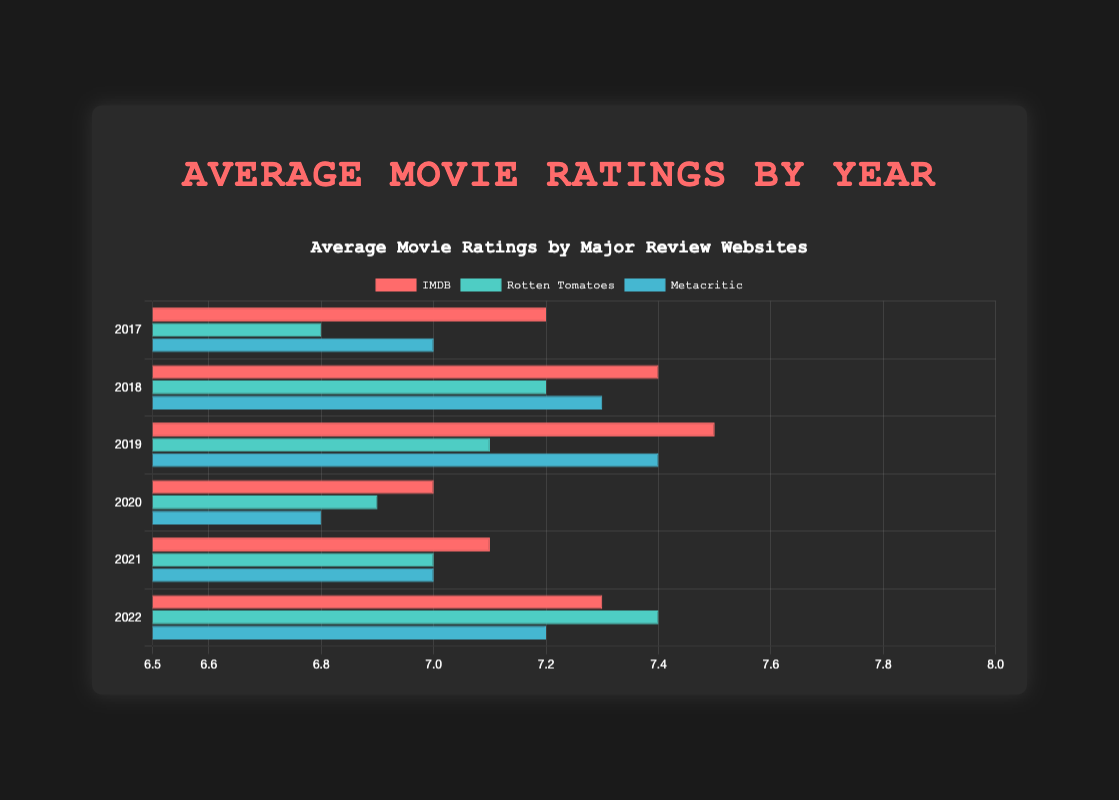What's the trend in average IMDB ratings from 2017 to 2022? Observe all the bars corresponding to IMDB from 2017 to 2022. They start from 7.2 in 2017, rise to 7.5 in 2019, dip to 7.0 in 2020, and then rise again to 7.3 in 2022.
Answer: The IMDB ratings fluctuate but show an overall slight increase Which year had the lowest average Rotten Tomatoes rating? Identify the shortest bar among the Rotten Tomatoes bars for all years. In 2017, the bar signifies 6.8, which is the lowest in comparison to other years.
Answer: 2017 What is the difference between the highest and lowest average ratings given by Metacritic? Identify Metacritic's highest rating (7.4 in 2019) and lowest rating (6.8 in 2020). Subtract the lowest from the highest: 7.4 - 6.8.
Answer: 0.6 In which year did Rotten Tomatoes give the highest rating, and what was the rating? Look for the tallest Rotten Tomatoes bar across all years. The highest rating is 7.4 in 2022.
Answer: 2022, 7.4 Which review website generally gave higher ratings on average during 2020? Compare the height of the bars for all three websites in 2020. The IMDB bar is higher (7.0) than Rotten Tomatoes (6.9) and Metacritic (6.8).
Answer: IMDB What is the average of the average ratings given by IMDB in 2018 and 2022? Add the average ratings given by IMDB in 2018 (7.4) and 2022 (7.3), then divide by 2. Calculation: (7.4 + 7.3) / 2 = 7.35.
Answer: 7.35 Which two years have the same average rating by Metacritic, and what is the rating? Observe and compare the height of the Metacritic bars. Both 2017 and 2021 have bars at the same height, indicating a rating of 7.0.
Answer: 2017 and 2021, 7.0 Did any website consistently rate movies higher than 7 every year? Look at bars for each website. IMDB ratings always exceed 7, whereas Rotten Tomatoes and Metacritic ratings sometimes fall below 7.
Answer: IMDB By how much did Rotten Tomatoes' ratings change from 2020 to 2022? Subtract the Rotten Tomatoes rating of 2020 (6.9) from that of 2022 (7.4). Calculation: 7.4 - 6.9 = 0.5.
Answer: 0.5 